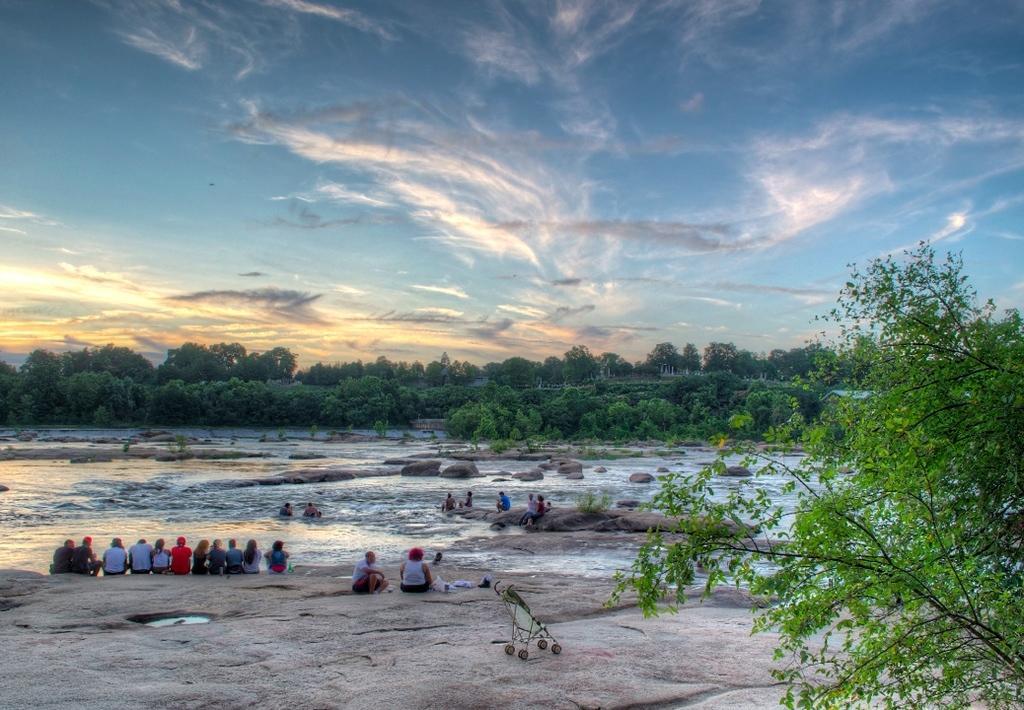In one or two sentences, can you explain what this image depicts? In this image I can see number of trees, clouds, the sky, water and I can also see number of people are sitting. 